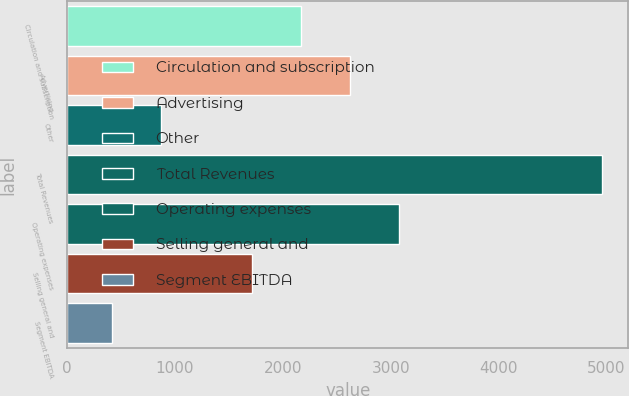Convert chart. <chart><loc_0><loc_0><loc_500><loc_500><bar_chart><fcel>Circulation and subscription<fcel>Advertising<fcel>Other<fcel>Total Revenues<fcel>Operating expenses<fcel>Selling general and<fcel>Segment EBITDA<nl><fcel>2170.9<fcel>2624.8<fcel>870.9<fcel>4956<fcel>3078.7<fcel>1717<fcel>417<nl></chart> 